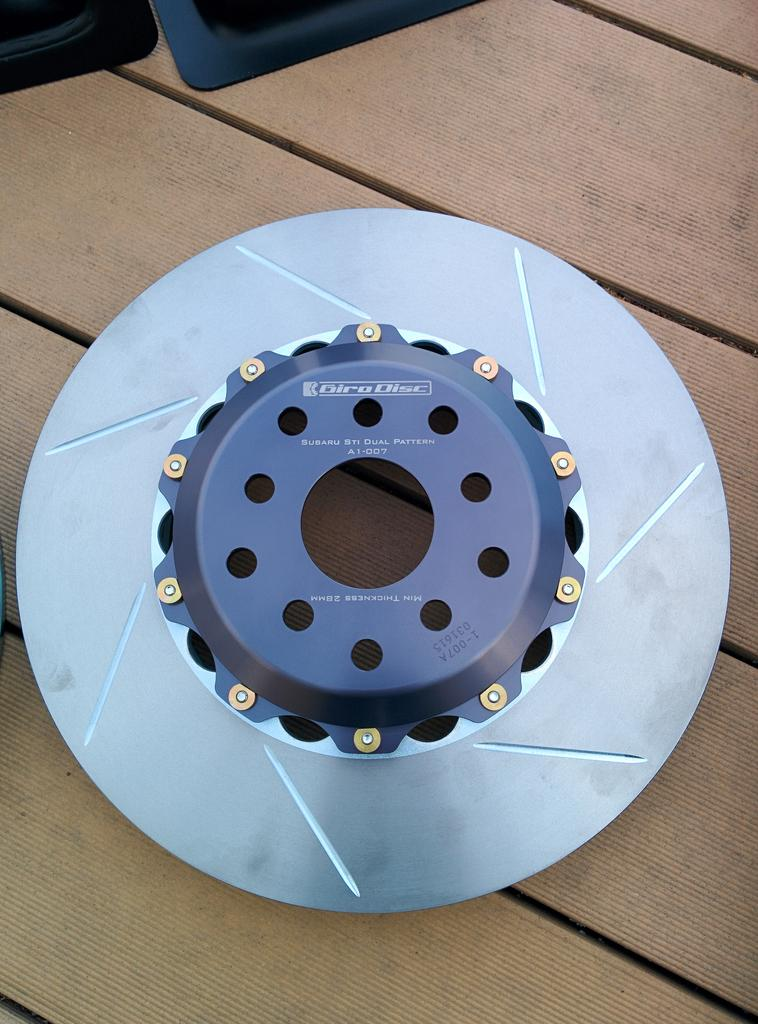What type of brake is visible in the image? There is a metal disc brake present in the image. Where is the metal disc brake located? The metal disc brake is placed on a wooden table top. What type of stocking is visible on the metal disc brake in the image? There is no stocking present on the metal disc brake in the image. How much sugar is contained within the metal disc brake in the image? There is no sugar present within the metal disc brake in the image. 